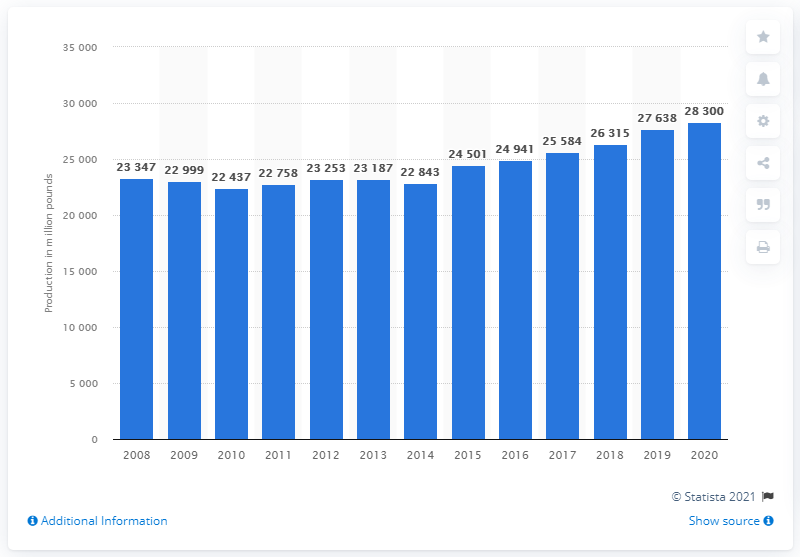Give some essential details in this illustration. In 2020, the commercial pork production in the United States was 26,315. 